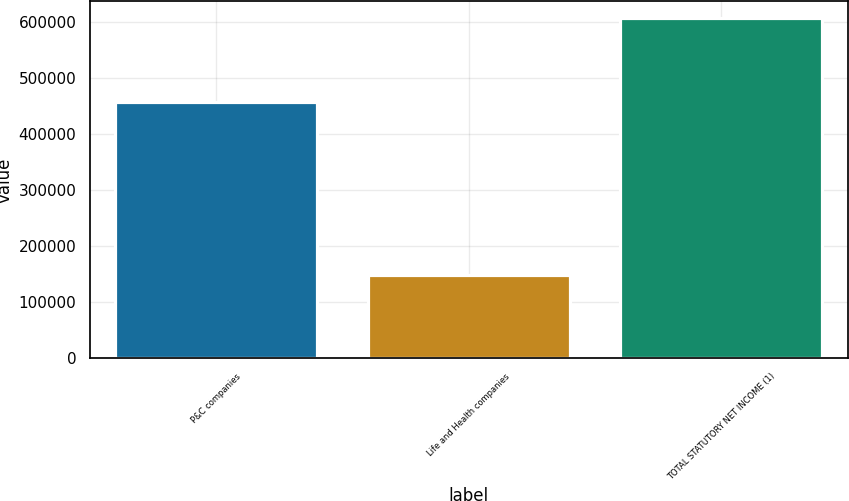Convert chart. <chart><loc_0><loc_0><loc_500><loc_500><bar_chart><fcel>P&C companies<fcel>Life and Health companies<fcel>TOTAL STATUTORY NET INCOME (1)<nl><fcel>457068<fcel>148851<fcel>605919<nl></chart> 